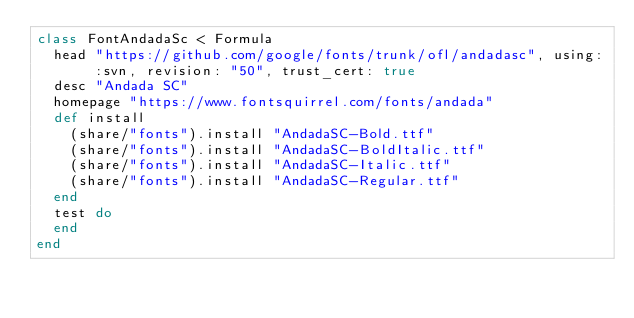<code> <loc_0><loc_0><loc_500><loc_500><_Ruby_>class FontAndadaSc < Formula
  head "https://github.com/google/fonts/trunk/ofl/andadasc", using: :svn, revision: "50", trust_cert: true
  desc "Andada SC"
  homepage "https://www.fontsquirrel.com/fonts/andada"
  def install
    (share/"fonts").install "AndadaSC-Bold.ttf"
    (share/"fonts").install "AndadaSC-BoldItalic.ttf"
    (share/"fonts").install "AndadaSC-Italic.ttf"
    (share/"fonts").install "AndadaSC-Regular.ttf"
  end
  test do
  end
end
</code> 